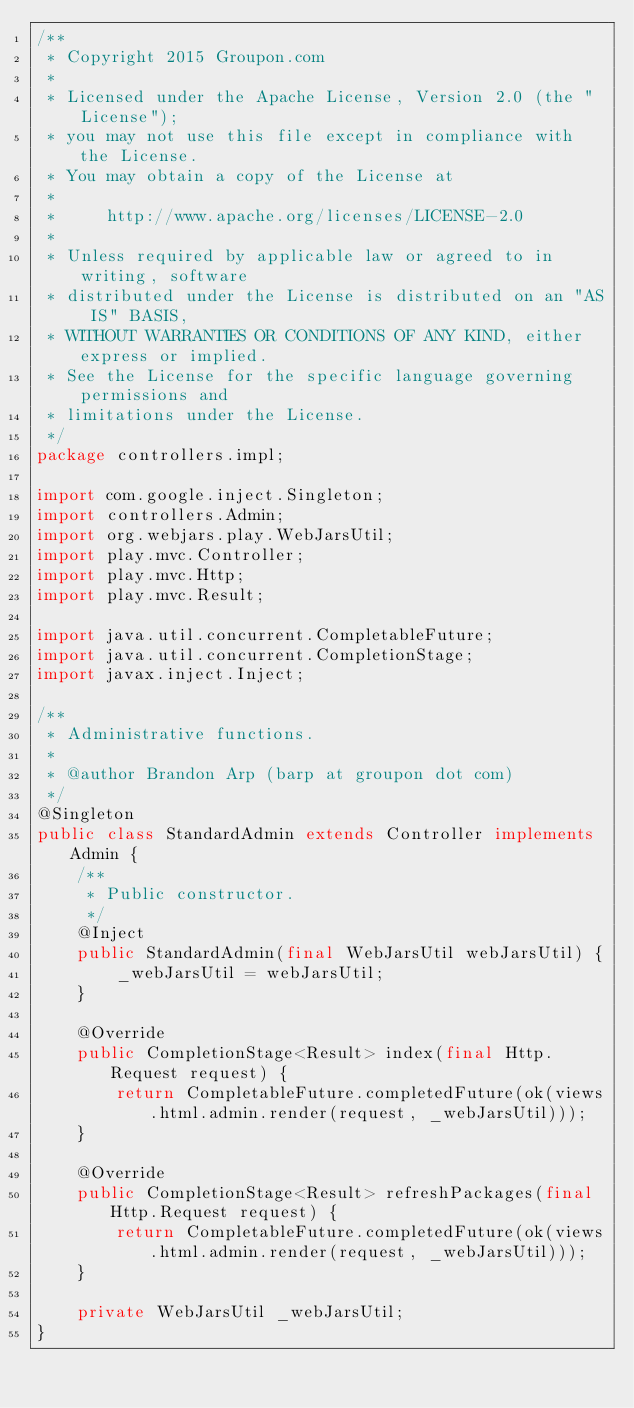<code> <loc_0><loc_0><loc_500><loc_500><_Java_>/**
 * Copyright 2015 Groupon.com
 *
 * Licensed under the Apache License, Version 2.0 (the "License");
 * you may not use this file except in compliance with the License.
 * You may obtain a copy of the License at
 *
 *     http://www.apache.org/licenses/LICENSE-2.0
 *
 * Unless required by applicable law or agreed to in writing, software
 * distributed under the License is distributed on an "AS IS" BASIS,
 * WITHOUT WARRANTIES OR CONDITIONS OF ANY KIND, either express or implied.
 * See the License for the specific language governing permissions and
 * limitations under the License.
 */
package controllers.impl;

import com.google.inject.Singleton;
import controllers.Admin;
import org.webjars.play.WebJarsUtil;
import play.mvc.Controller;
import play.mvc.Http;
import play.mvc.Result;

import java.util.concurrent.CompletableFuture;
import java.util.concurrent.CompletionStage;
import javax.inject.Inject;

/**
 * Administrative functions.
 *
 * @author Brandon Arp (barp at groupon dot com)
 */
@Singleton
public class StandardAdmin extends Controller implements Admin {
    /**
     * Public constructor.
     */
    @Inject
    public StandardAdmin(final WebJarsUtil webJarsUtil) {
        _webJarsUtil = webJarsUtil;
    }

    @Override
    public CompletionStage<Result> index(final Http.Request request) {
        return CompletableFuture.completedFuture(ok(views.html.admin.render(request, _webJarsUtil)));
    }

    @Override
    public CompletionStage<Result> refreshPackages(final Http.Request request) {
        return CompletableFuture.completedFuture(ok(views.html.admin.render(request, _webJarsUtil)));
    }

    private WebJarsUtil _webJarsUtil;
}
</code> 